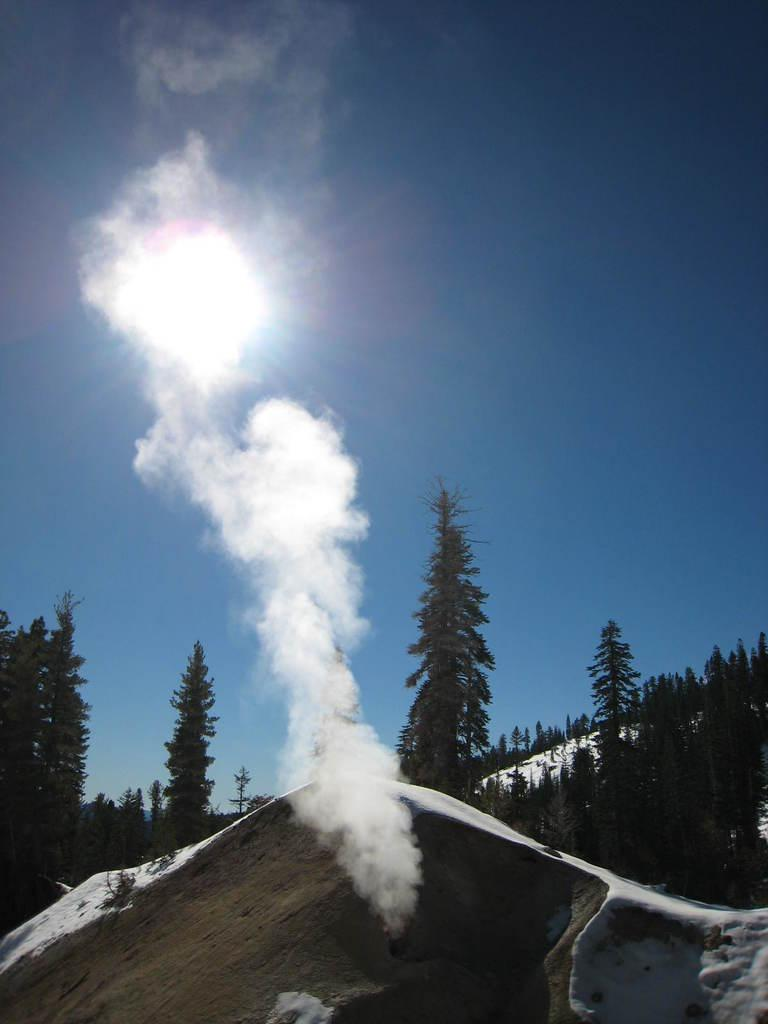What type of vegetation is present on the ground in the front of the image? There is grass on the ground in the front of the image. What weather condition is depicted in the image? There is snow in the image. What can be seen in the background of the image? There are trees in the background of the image. What is visible in the center of the image? There is smoke visible in the center of the image. What type of baseball equipment is visible in the image? There is no baseball equipment present in the image. Can you provide a list of the items that need help in the image? There are no items in the image that require help, as the image does not depict any living beings or objects in need of assistance. 